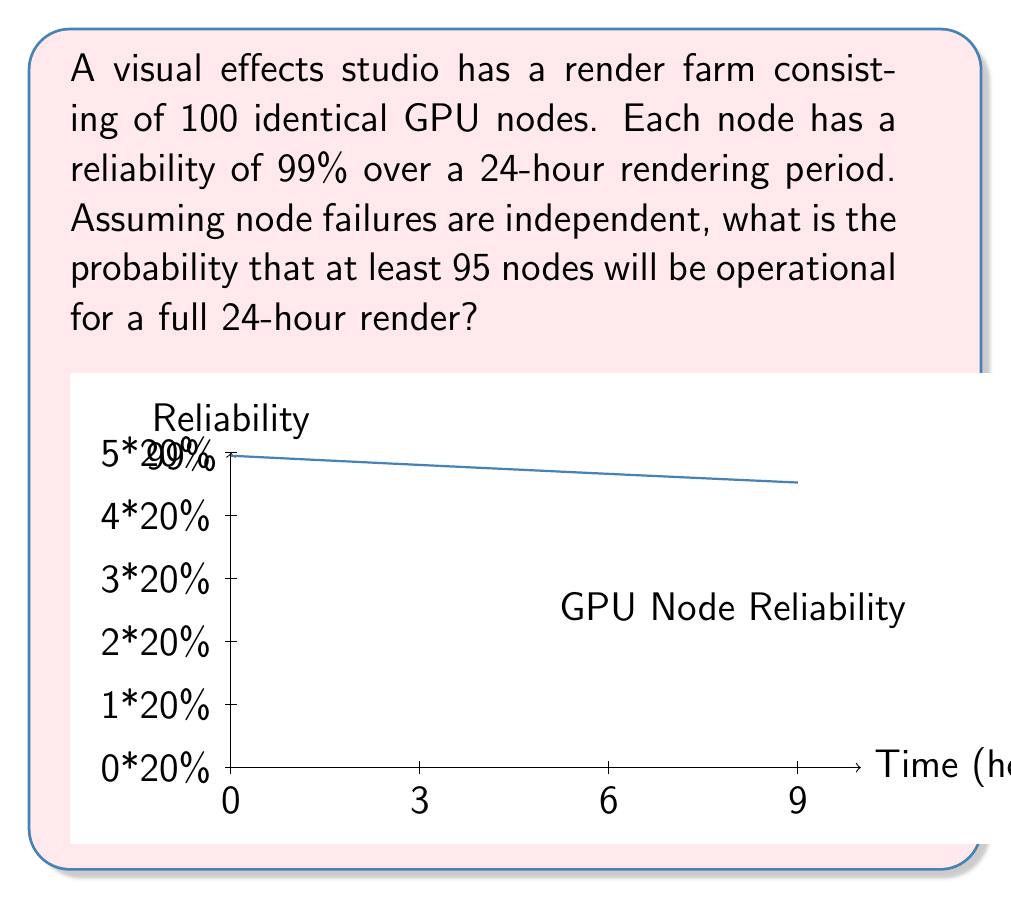Help me with this question. Let's approach this step-by-step:

1) First, we need to recognize this as a binomial probability problem. We have 100 independent trials (nodes), each with a success probability of 0.99.

2) We want to find the probability of 95 or more successes out of 100 trials. This can be expressed as:

   $$P(X \geq 95) = 1 - P(X < 95) = 1 - P(X \leq 94)$$

   where X is the number of operational nodes.

3) The probability can be calculated using the cumulative binomial distribution function:

   $$P(X \geq 95) = 1 - \sum_{k=0}^{94} \binom{100}{k} (0.99)^k (0.01)^{100-k}$$

4) This calculation is complex to do by hand, so we would typically use statistical software or a calculator with a binomial cumulative distribution function.

5) Using such a tool, we find:

   $$P(X \geq 95) \approx 0.9998$$

6) Interpretation: There is approximately a 99.98% chance that 95 or more nodes will be operational for the full 24-hour render.

This high probability reflects the high individual reliability of each node and the redundancy built into the system.
Answer: 0.9998 or 99.98% 